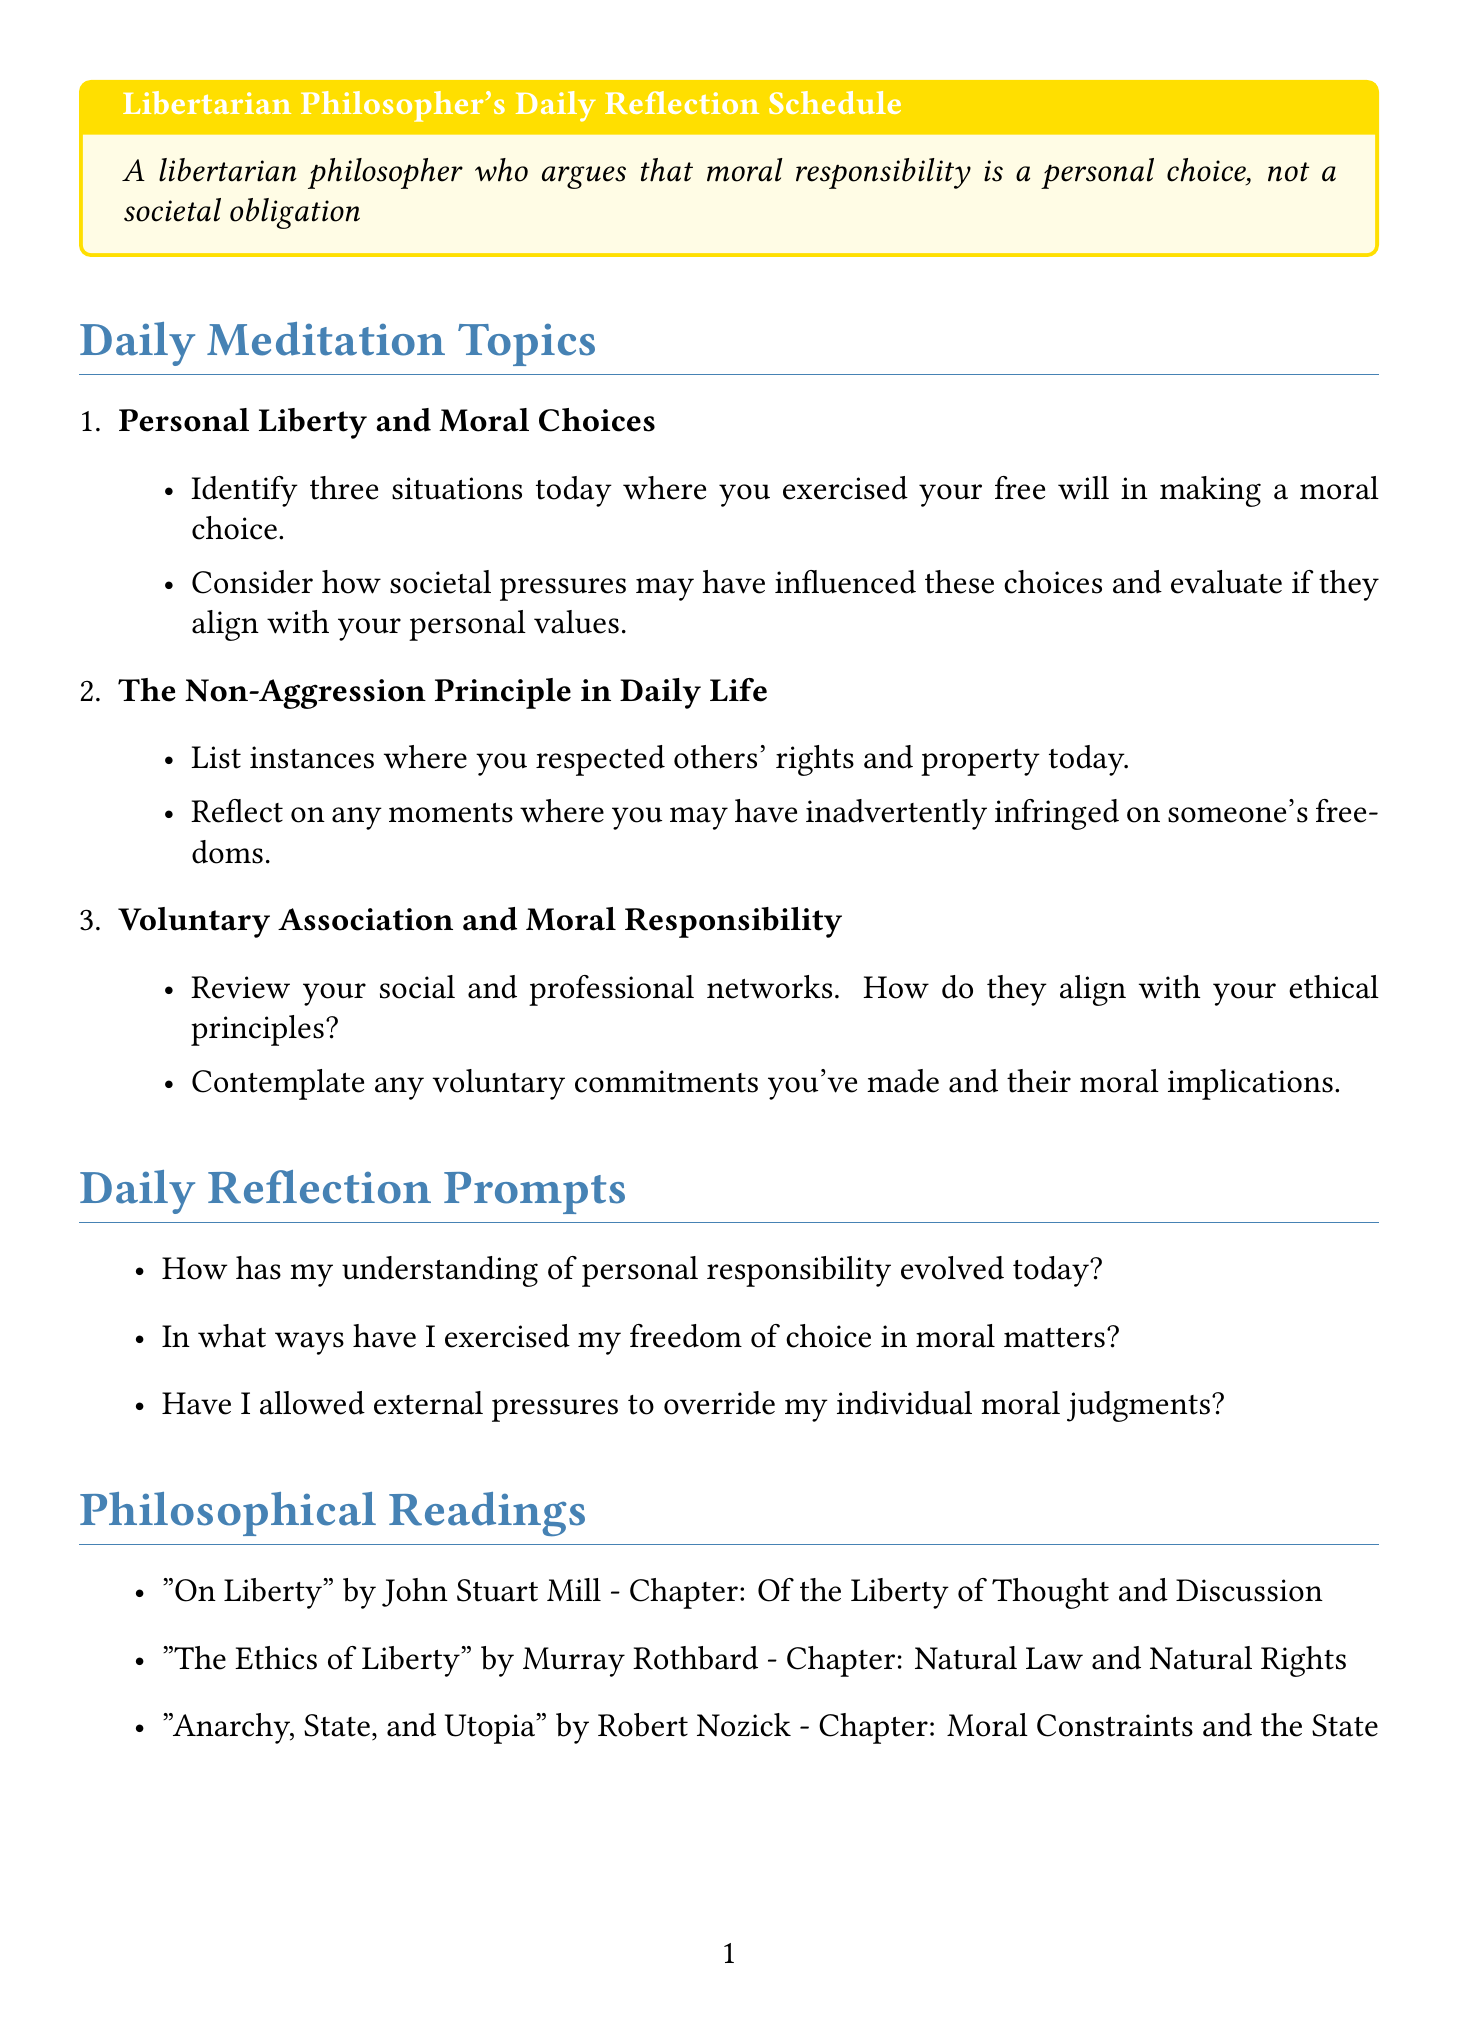What is the title of the first meditation topic? The title of the first meditation topic is listed in the document under the section "Daily Meditation Topics."
Answer: Personal Liberty and Moral Choices How many reflection prompts are included in the schedule? The number of reflection prompts can be found in the section titled "Daily Reflection Prompts."
Answer: Seven Who is the author of "The Ethics of Liberty"? The author's name is mentioned in the list of philosophical readings in the document.
Answer: Murray Rothbard What is the main focus of the second meditation topic? It is indicated in the description for the second meditation topic under "Daily Meditation Topics."
Answer: The libertarian non-aggression principle applies to interactions What is the purpose of the "Ethical Decision Journal"? The document describes each practical exercise, including its aim in a description.
Answer: To keep a daily log of moral choices How do the exercises relate to libertarian principles? This requires understanding how the exercises are designed to promote libertarian ideas as detailed in the document.
Answer: They encourage personal responsibility and ethical independence What chapter of "On Liberty" is referenced? The chapter title is included in the list of philosophical readings within the document.
Answer: Of the Liberty of Thought and Discussion What is the "Non-Coercion Challenge"? Its definition is found in the practical exercises section, outlining its goal.
Answer: To resolve conflicts without resorting to force or manipulation 